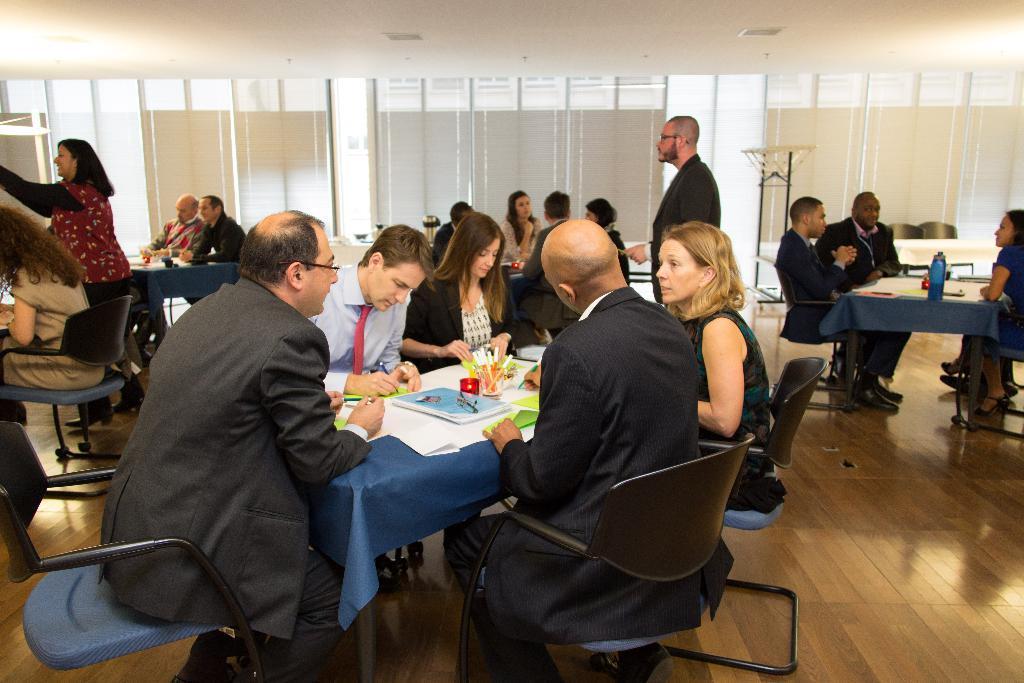Describe this image in one or two sentences. There are some people sitting in the chairs around a table on which a book, paper and pens were placed. There are men and women in this group. One of the man is standing. In the background there is a wall. 